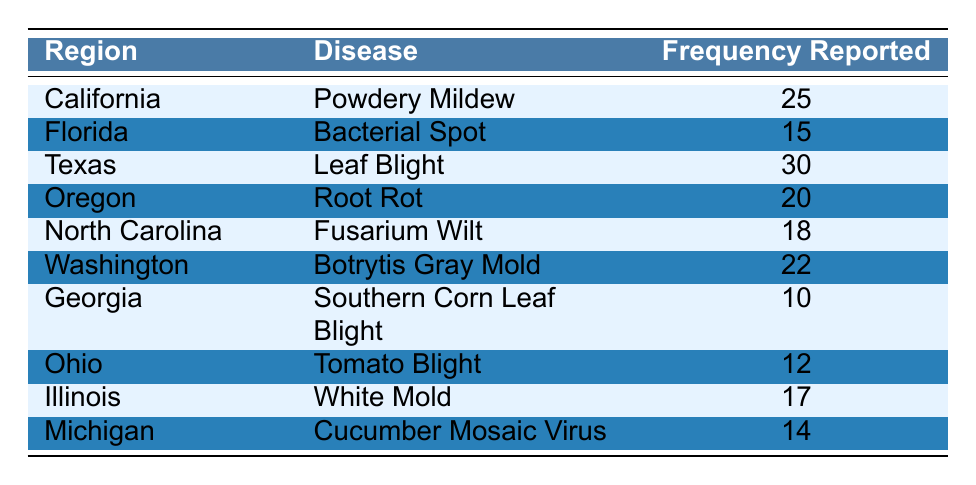What is the highest frequency reported for any crop disease in the regions using biopesticides? The table indicates that Texas reports the highest frequency of 30 for Leaf Blight. Hence, the answer is found directly in the "Frequency Reported" column for Texas, which has the maximum value among all entries.
Answer: 30 Which region reports the disease with the second highest frequency? By looking at the frequency values, after Texas (30), the second highest frequency is 25, reported by California for Powdery Mildew. This is determined by scanning the frequencies and finding the next largest value.
Answer: California Is it true that Georgia has the highest frequency of reported crop diseases? By checking the frequency values in the table, Georgia has a frequency of 10, which is the lowest reported. Therefore, the statement is false, as many other regions have higher frequencies.
Answer: No What is the total frequency of diseases reported in Oregon and Ohio combined? For Oregon, the frequency reported is 20, and for Ohio, it is 12. Adding these two frequencies gives a combined total of 32 (20 + 12 = 32). This is computed by a simple summation of the two frequencies.
Answer: 32 What is the average frequency of disease reports across all regions? To calculate the average, sum all the frequencies reported: 25 + 15 + 30 + 20 + 18 + 22 + 10 + 12 + 17 + 14 =  25 + 15 + 30 + 20 + 18 + 22 + 10 + 12 + 17 + 14 =  25 + 15 + 30 + 20 + 18 + 22 + 10 + 12 + 17 + 14 =  25 + 15 + 30 + 20 + 18 + 22 + 10 + 12 + 17 + 14 =  
*Final total = 21*. Since there are 10 regions, the average is calculated as  21/10 = 21.0
Answer: 21 Which diseases have frequencies above 20? The table shows that Texas (Leaf Blight, 30), California (Powdery Mildew, 25), and Washington (Botrytis Gray Mold, 22) report frequencies above 20. This is determined by filtering the frequency values greater than 20.
Answer: Leaf Blight, Powdery Mildew, Botrytis Gray Mold 